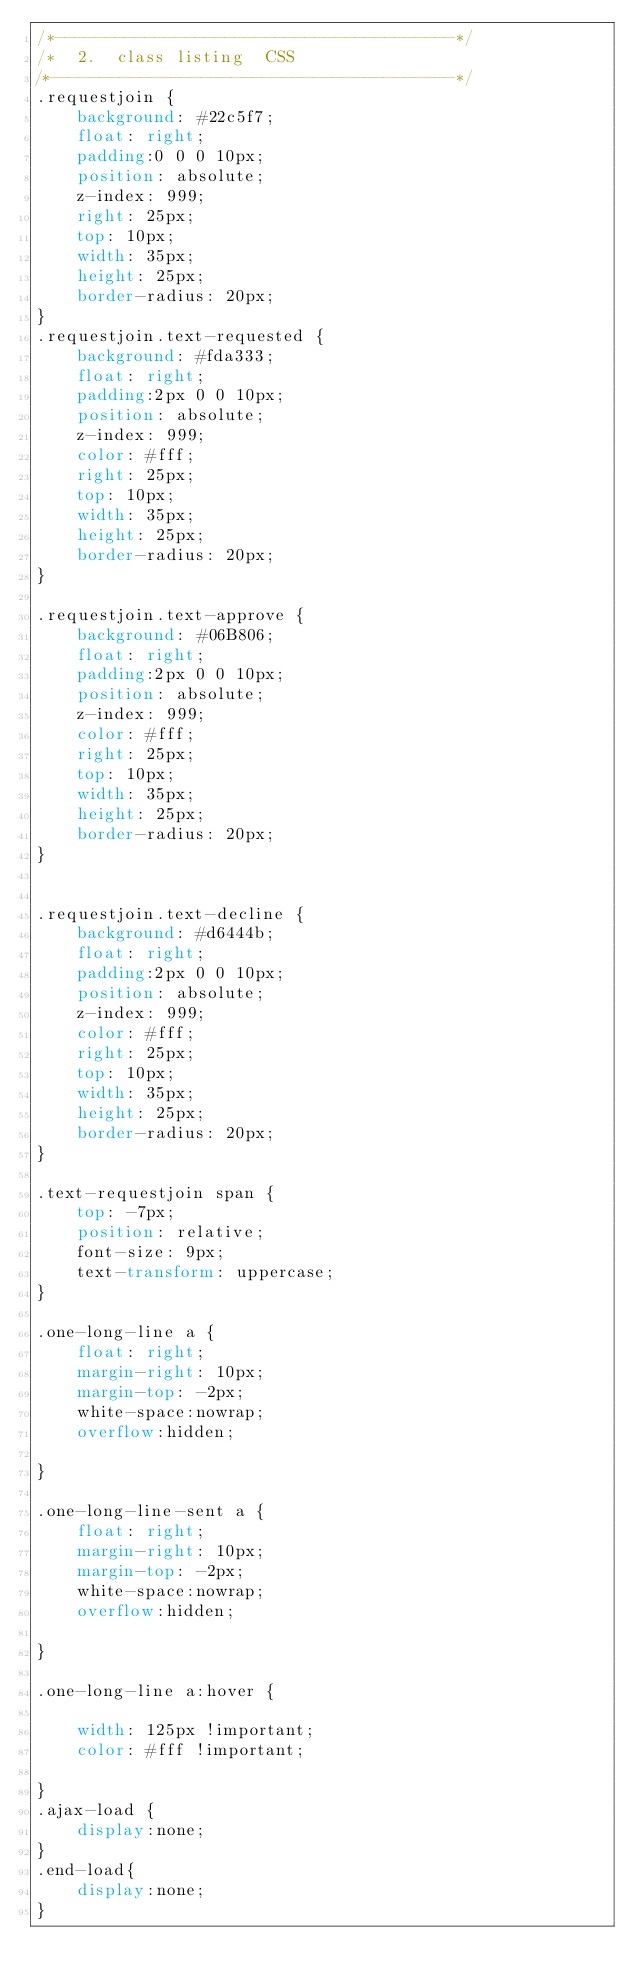<code> <loc_0><loc_0><loc_500><loc_500><_CSS_>/*----------------------------------------*/
/*  2.  class listing  CSS
/*----------------------------------------*/
.requestjoin {
    background: #22c5f7;
    float: right;
    padding:0 0 0 10px;
    position: absolute;
    z-index: 999;
    right: 25px;
    top: 10px;
    width: 35px;
    height: 25px;
    border-radius: 20px;
}
.requestjoin.text-requested {
    background: #fda333;
    float: right;
    padding:2px 0 0 10px;
    position: absolute;
    z-index: 999;
    color: #fff;
    right: 25px;
    top: 10px;
    width: 35px;
    height: 25px;
    border-radius: 20px;
}

.requestjoin.text-approve {
    background: #06B806;
    float: right;
    padding:2px 0 0 10px;
    position: absolute;
    z-index: 999;
    color: #fff;
    right: 25px;
    top: 10px;
    width: 35px;
    height: 25px;
    border-radius: 20px;
}


.requestjoin.text-decline {
    background: #d6444b;
    float: right;
    padding:2px 0 0 10px;
    position: absolute;
    z-index: 999;
    color: #fff;
    right: 25px;
    top: 10px;
    width: 35px;
    height: 25px;
    border-radius: 20px;
}

.text-requestjoin span {
    top: -7px;
    position: relative;
    font-size: 9px;
    text-transform: uppercase;
}

.one-long-line a {
    float: right;
    margin-right: 10px;
    margin-top: -2px;
    white-space:nowrap;
    overflow:hidden;

}

.one-long-line-sent a {
    float: right;
    margin-right: 10px;
    margin-top: -2px;
    white-space:nowrap;
    overflow:hidden;

}

.one-long-line a:hover {

    width: 125px !important;
    color: #fff !important;

}
.ajax-load {
    display:none;
}
.end-load{
    display:none;
}</code> 